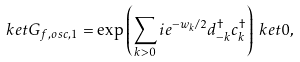<formula> <loc_0><loc_0><loc_500><loc_500>\ k e t { G _ { f , o s c , 1 } } & = \exp \left ( \sum _ { k > 0 } i e ^ { - w _ { k } / 2 } d _ { - k } ^ { \dagger } c _ { k } ^ { \dagger } \right ) \ k e t { 0 } ,</formula> 